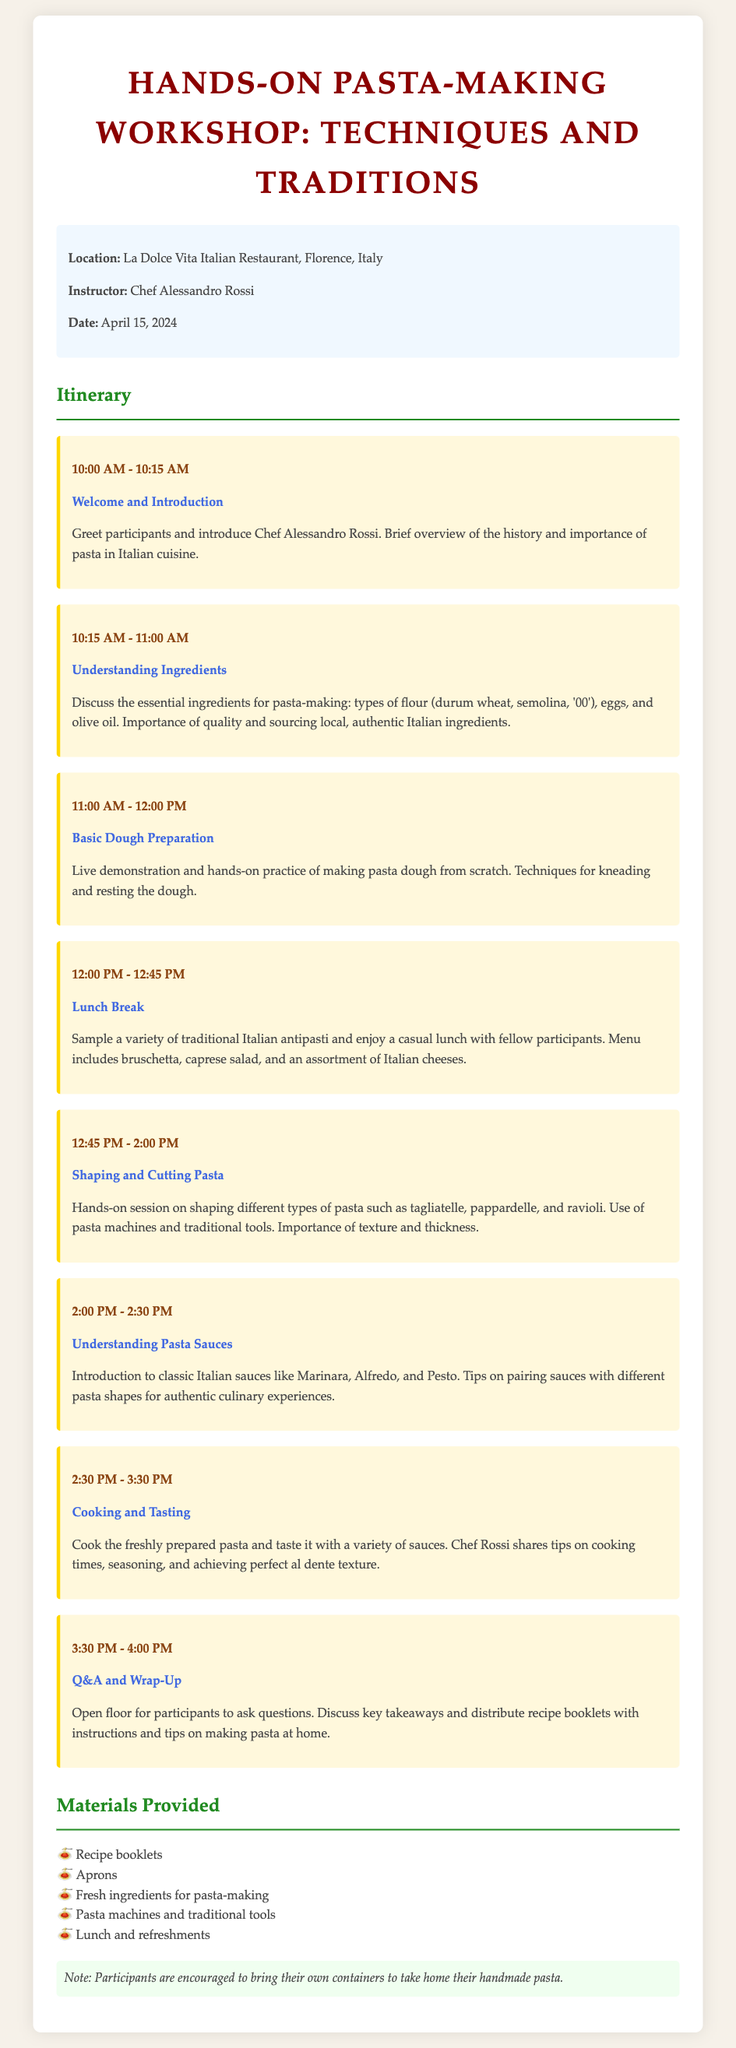What is the date of the workshop? The date of the workshop is specified in the document as April 15, 2024.
Answer: April 15, 2024 Who is the instructor for the workshop? The workshop features Chef Alessandro Rossi as the instructor.
Answer: Chef Alessandro Rossi What time does the workshop start? The document clearly states that the workshop begins at 10:00 AM.
Answer: 10:00 AM What type of pasta will participants learn to make? Participants will learn to make different types of pasta, including tagliatelle, pappardelle, and ravioli.
Answer: Tagliatelle, pappardelle, ravioli Which traditional Italian dish is not mentioned in the sauces section? The section does not mention Alfredo as a traditional Italian dish.
Answer: Alfredo How long is the lunch break during the workshop? The length of the lunch break is detailed as 45 minutes from 12:00 PM to 12:45 PM.
Answer: 45 minutes What materials are provided to participants? The document lists five materials that are provided, including recipe booklets and aprons.
Answer: Recipe booklets, aprons, fresh ingredients, pasta machines, lunch What is the main focus of the workshop? The main focus of the workshop is to teach techniques and traditions of pasta-making.
Answer: Techniques and traditions of pasta-making 